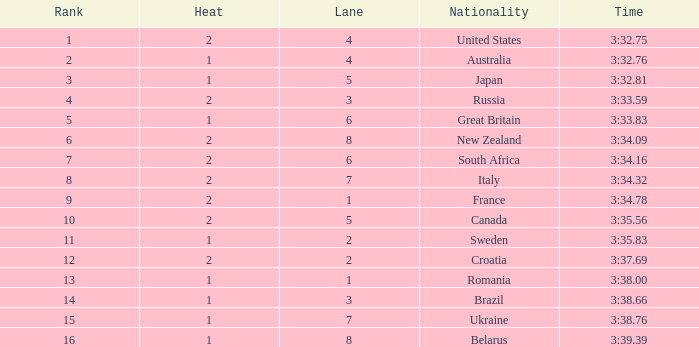Can you tell me the Time that has the Heat of 1, and the Lane of 2? 3:35.83. 